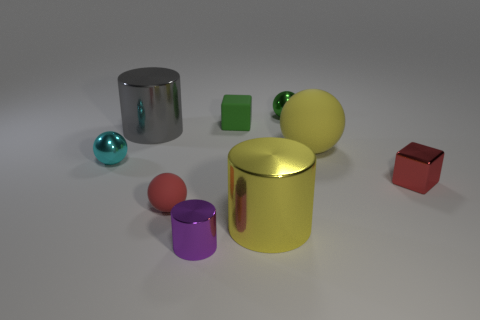What number of tiny purple things are the same shape as the large gray metal object?
Make the answer very short. 1. There is a red thing that is left of the tiny rubber object that is behind the tiny cyan object; what is its material?
Give a very brief answer. Rubber. There is a tiny metal thing that is the same color as the small matte block; what is its shape?
Offer a very short reply. Sphere. Is there a yellow object that has the same material as the purple cylinder?
Offer a very short reply. Yes. The red metal thing has what shape?
Ensure brevity in your answer.  Cube. What number of red things are there?
Your answer should be very brief. 2. There is a big cylinder that is behind the rubber sphere behind the small cyan metal ball; what is its color?
Offer a terse response. Gray. What color is the metal block that is the same size as the purple cylinder?
Your response must be concise. Red. Is there a small metallic sphere that has the same color as the small cylinder?
Offer a terse response. No. Is there a yellow metallic cylinder?
Your answer should be very brief. Yes. 